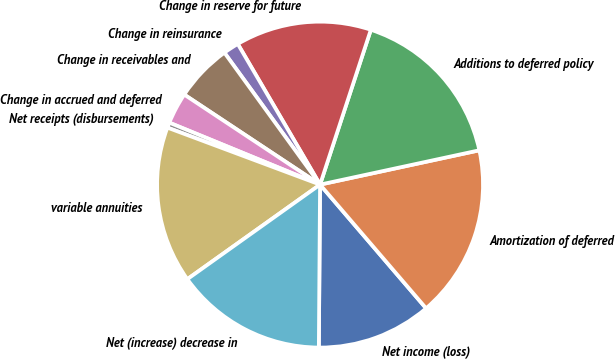Convert chart to OTSL. <chart><loc_0><loc_0><loc_500><loc_500><pie_chart><fcel>Net income (loss)<fcel>Amortization of deferred<fcel>Additions to deferred policy<fcel>Change in reserve for future<fcel>Change in reinsurance<fcel>Change in receivables and<fcel>Change in accrued and deferred<fcel>Net receipts (disbursements)<fcel>variable annuities<fcel>Net (increase) decrease in<nl><fcel>11.4%<fcel>17.1%<fcel>16.58%<fcel>13.47%<fcel>1.56%<fcel>5.7%<fcel>3.11%<fcel>0.52%<fcel>15.54%<fcel>15.03%<nl></chart> 